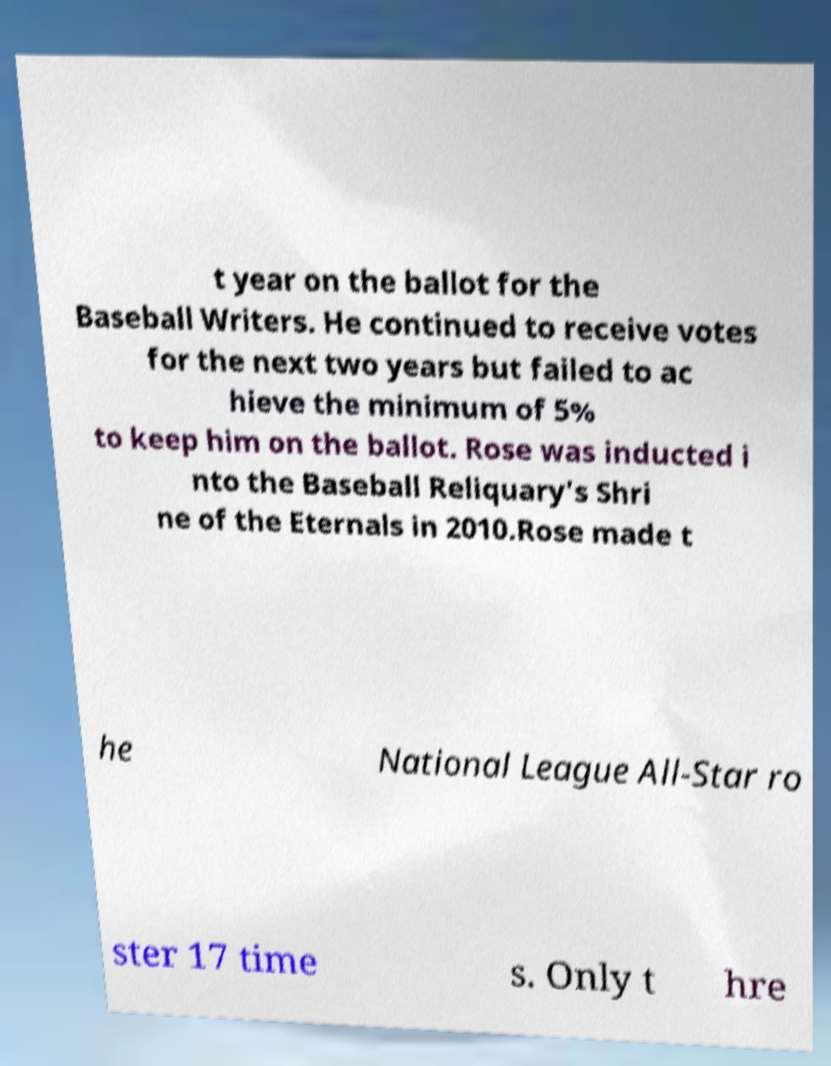Can you accurately transcribe the text from the provided image for me? t year on the ballot for the Baseball Writers. He continued to receive votes for the next two years but failed to ac hieve the minimum of 5% to keep him on the ballot. Rose was inducted i nto the Baseball Reliquary's Shri ne of the Eternals in 2010.Rose made t he National League All-Star ro ster 17 time s. Only t hre 